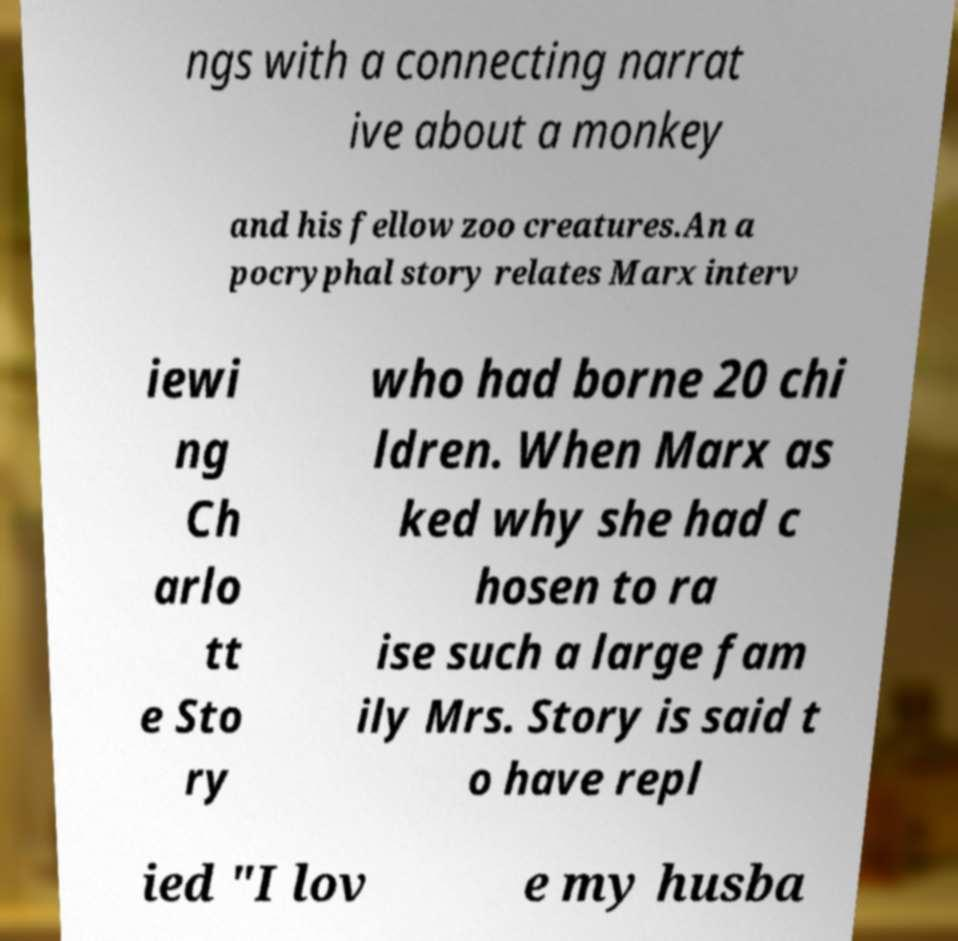There's text embedded in this image that I need extracted. Can you transcribe it verbatim? ngs with a connecting narrat ive about a monkey and his fellow zoo creatures.An a pocryphal story relates Marx interv iewi ng Ch arlo tt e Sto ry who had borne 20 chi ldren. When Marx as ked why she had c hosen to ra ise such a large fam ily Mrs. Story is said t o have repl ied "I lov e my husba 